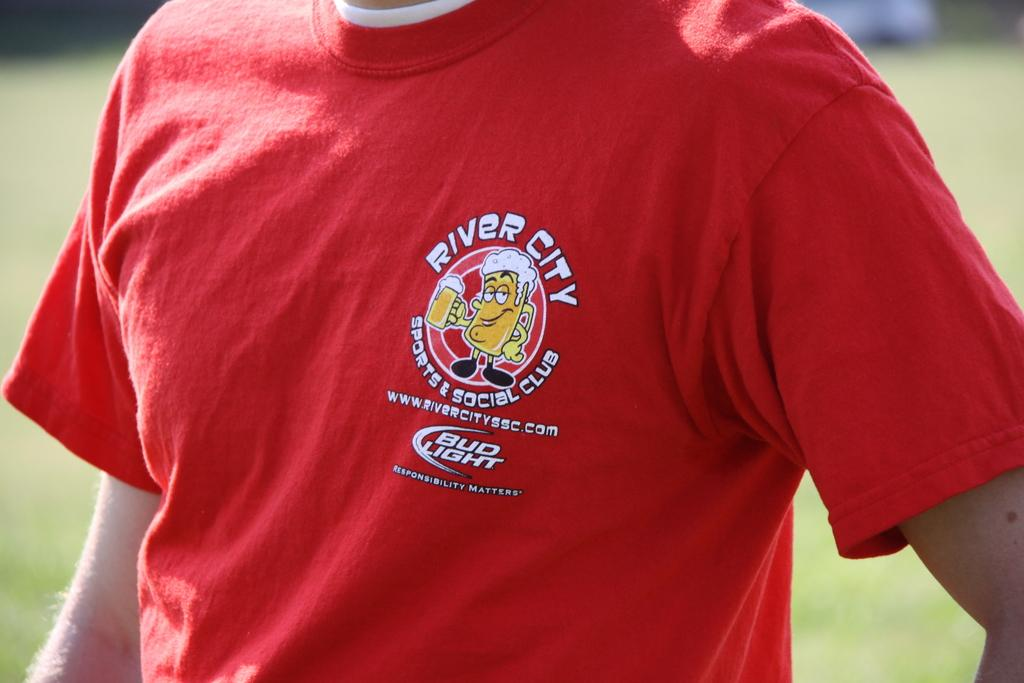<image>
Describe the image concisely. A person wears a red t-shirt that says River City above a cartoon of a beer mug. 